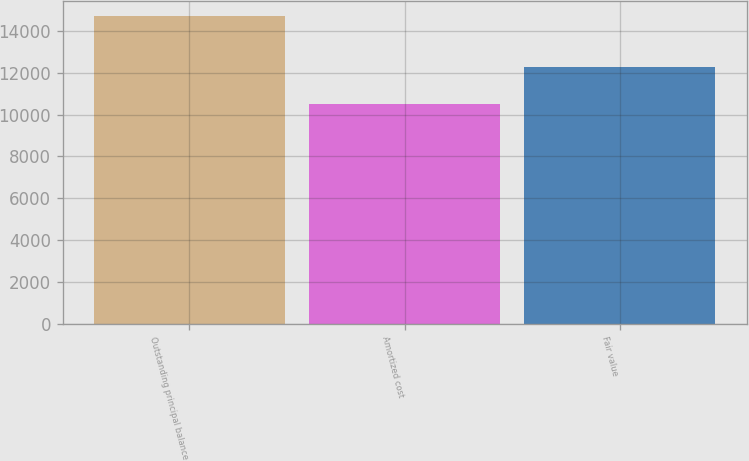Convert chart to OTSL. <chart><loc_0><loc_0><loc_500><loc_500><bar_chart><fcel>Outstanding principal balance<fcel>Amortized cost<fcel>Fair value<nl><fcel>14718<fcel>10492<fcel>12293<nl></chart> 